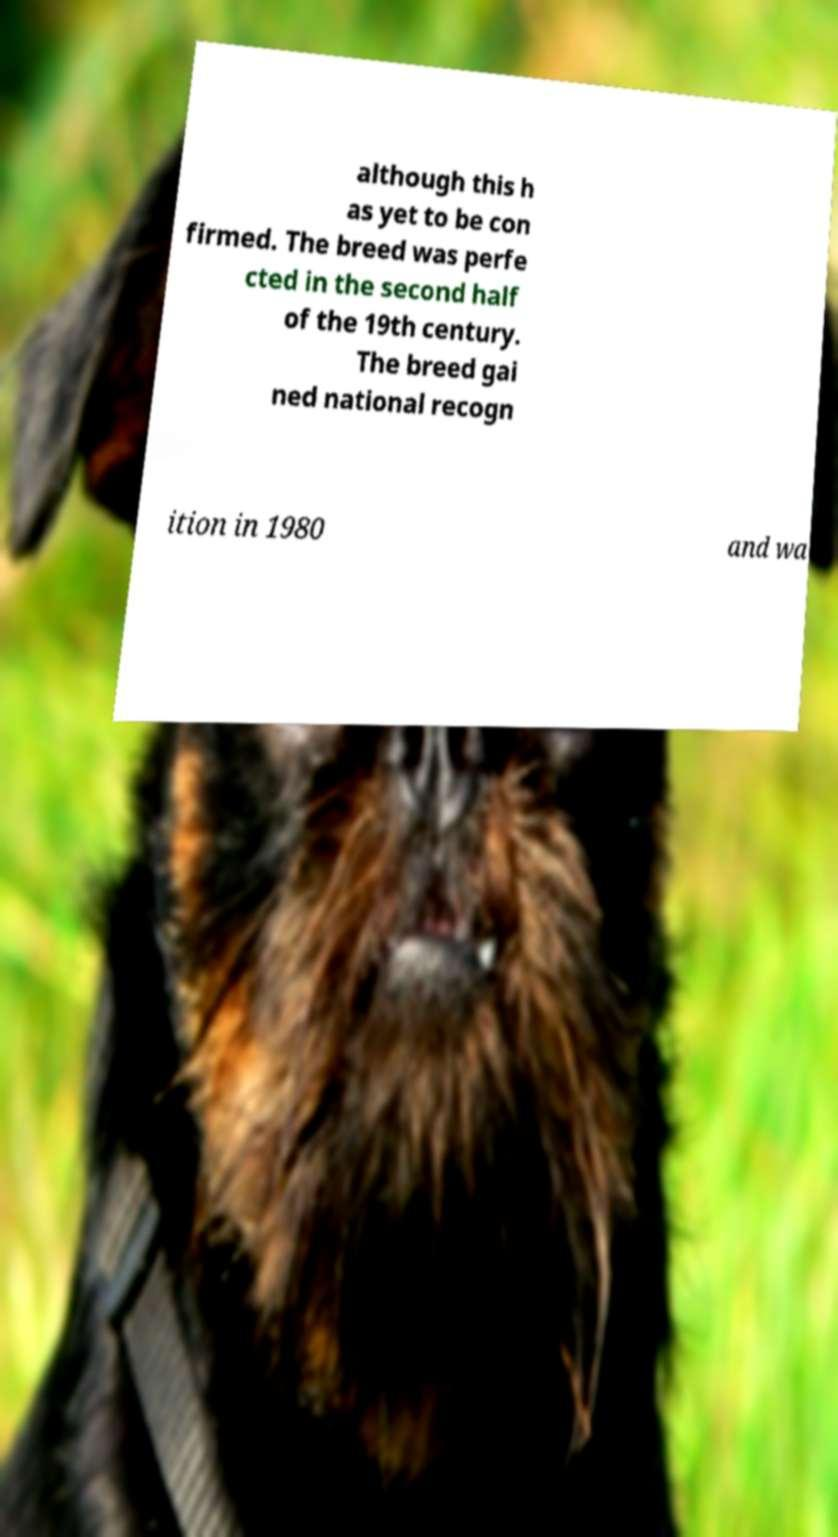There's text embedded in this image that I need extracted. Can you transcribe it verbatim? although this h as yet to be con firmed. The breed was perfe cted in the second half of the 19th century. The breed gai ned national recogn ition in 1980 and wa 